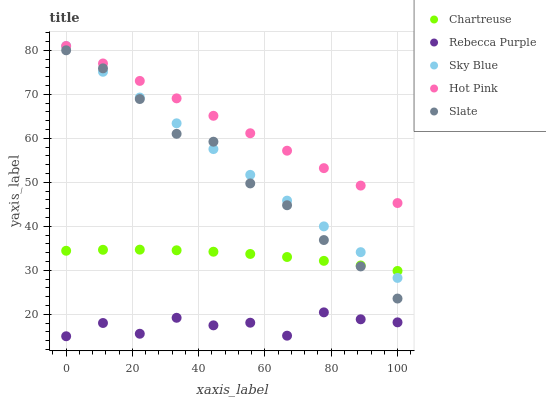Does Rebecca Purple have the minimum area under the curve?
Answer yes or no. Yes. Does Hot Pink have the maximum area under the curve?
Answer yes or no. Yes. Does Sky Blue have the minimum area under the curve?
Answer yes or no. No. Does Sky Blue have the maximum area under the curve?
Answer yes or no. No. Is Sky Blue the smoothest?
Answer yes or no. Yes. Is Rebecca Purple the roughest?
Answer yes or no. Yes. Is Chartreuse the smoothest?
Answer yes or no. No. Is Chartreuse the roughest?
Answer yes or no. No. Does Rebecca Purple have the lowest value?
Answer yes or no. Yes. Does Sky Blue have the lowest value?
Answer yes or no. No. Does Hot Pink have the highest value?
Answer yes or no. Yes. Does Chartreuse have the highest value?
Answer yes or no. No. Is Rebecca Purple less than Hot Pink?
Answer yes or no. Yes. Is Hot Pink greater than Rebecca Purple?
Answer yes or no. Yes. Does Hot Pink intersect Sky Blue?
Answer yes or no. Yes. Is Hot Pink less than Sky Blue?
Answer yes or no. No. Is Hot Pink greater than Sky Blue?
Answer yes or no. No. Does Rebecca Purple intersect Hot Pink?
Answer yes or no. No. 